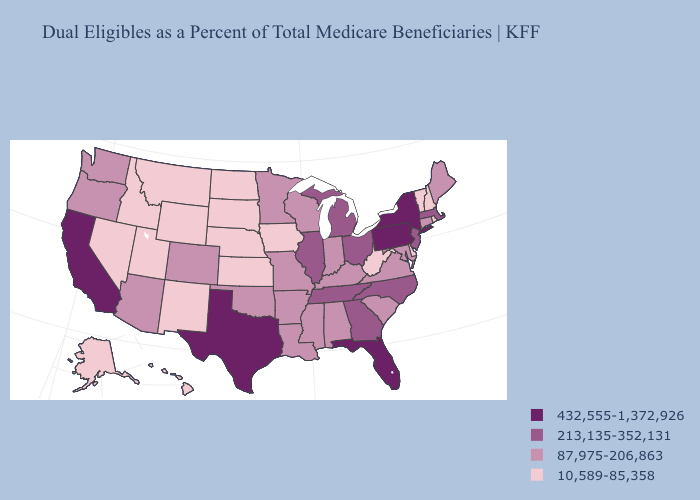Among the states that border Virginia , does West Virginia have the lowest value?
Short answer required. Yes. What is the lowest value in the Northeast?
Quick response, please. 10,589-85,358. What is the lowest value in the South?
Keep it brief. 10,589-85,358. What is the value of New Jersey?
Short answer required. 213,135-352,131. Which states have the lowest value in the MidWest?
Short answer required. Iowa, Kansas, Nebraska, North Dakota, South Dakota. Among the states that border Nevada , which have the lowest value?
Answer briefly. Idaho, Utah. Name the states that have a value in the range 213,135-352,131?
Write a very short answer. Georgia, Illinois, Massachusetts, Michigan, New Jersey, North Carolina, Ohio, Tennessee. What is the value of Hawaii?
Answer briefly. 10,589-85,358. Does the first symbol in the legend represent the smallest category?
Answer briefly. No. What is the value of Montana?
Be succinct. 10,589-85,358. Name the states that have a value in the range 213,135-352,131?
Answer briefly. Georgia, Illinois, Massachusetts, Michigan, New Jersey, North Carolina, Ohio, Tennessee. What is the highest value in the Northeast ?
Keep it brief. 432,555-1,372,926. What is the value of Kentucky?
Keep it brief. 87,975-206,863. Does New York have the highest value in the USA?
Keep it brief. Yes. What is the value of Maine?
Give a very brief answer. 87,975-206,863. 